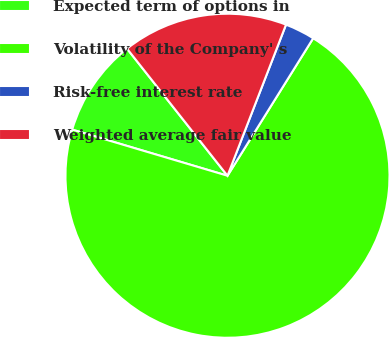Convert chart to OTSL. <chart><loc_0><loc_0><loc_500><loc_500><pie_chart><fcel>Expected term of options in<fcel>Volatility of the Company' s<fcel>Risk-free interest rate<fcel>Weighted average fair value<nl><fcel>9.76%<fcel>70.73%<fcel>2.99%<fcel>16.53%<nl></chart> 